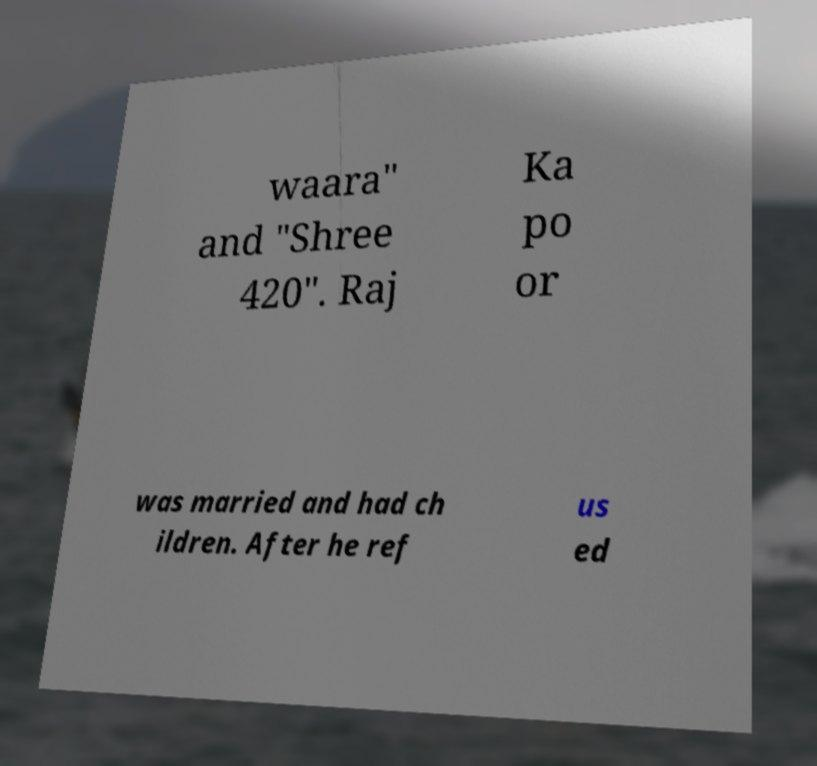Can you accurately transcribe the text from the provided image for me? waara" and "Shree 420". Raj Ka po or was married and had ch ildren. After he ref us ed 